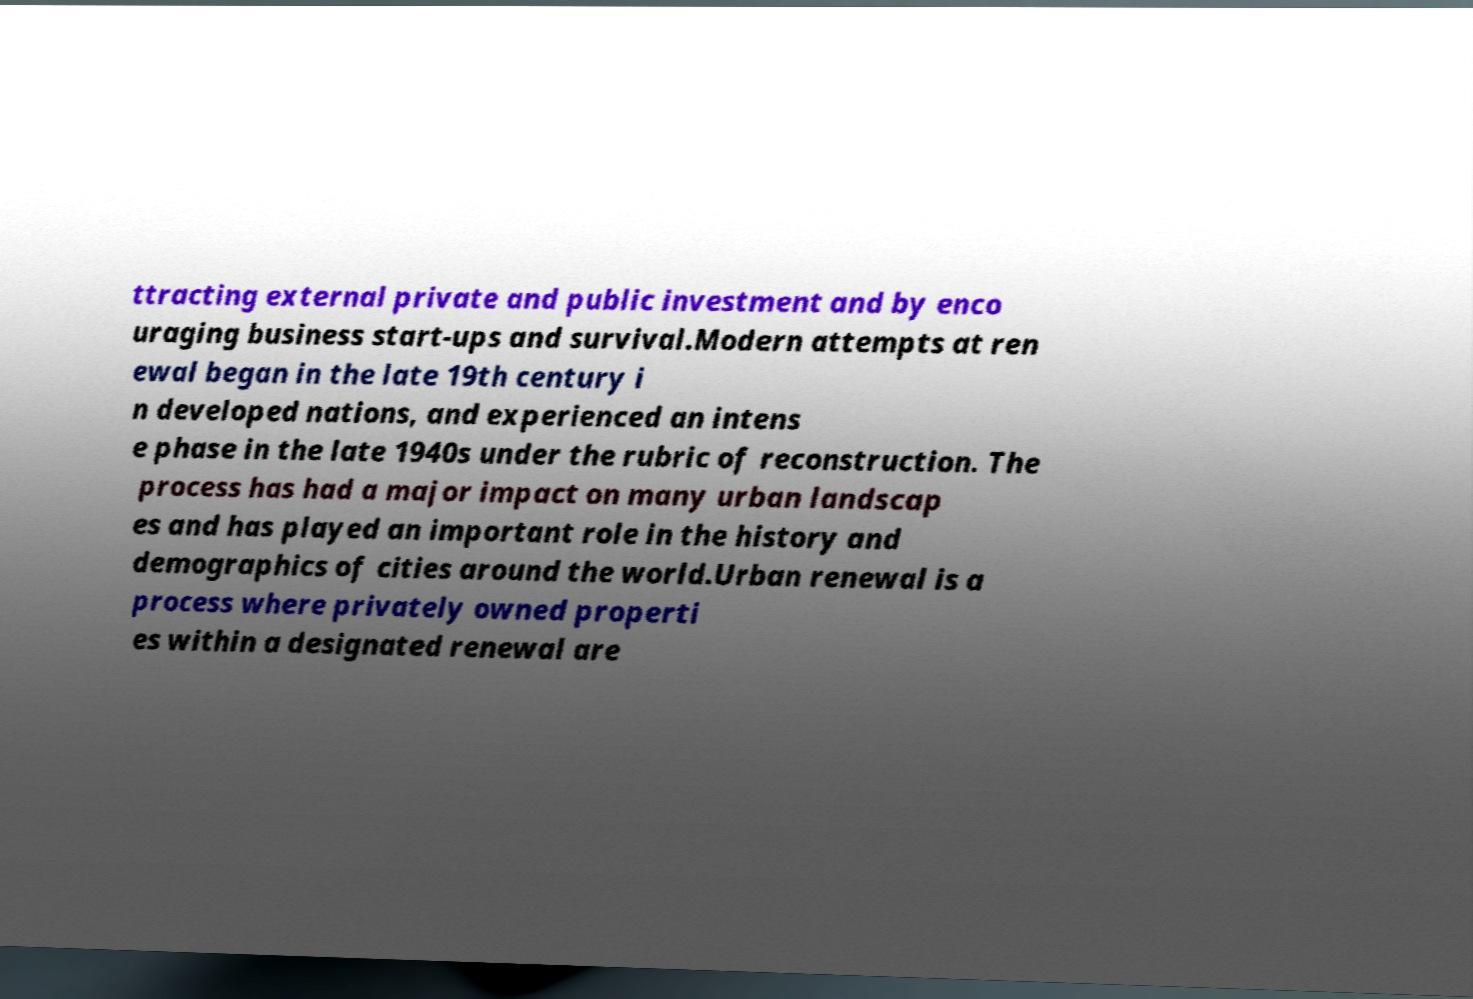For documentation purposes, I need the text within this image transcribed. Could you provide that? ttracting external private and public investment and by enco uraging business start-ups and survival.Modern attempts at ren ewal began in the late 19th century i n developed nations, and experienced an intens e phase in the late 1940s under the rubric of reconstruction. The process has had a major impact on many urban landscap es and has played an important role in the history and demographics of cities around the world.Urban renewal is a process where privately owned properti es within a designated renewal are 